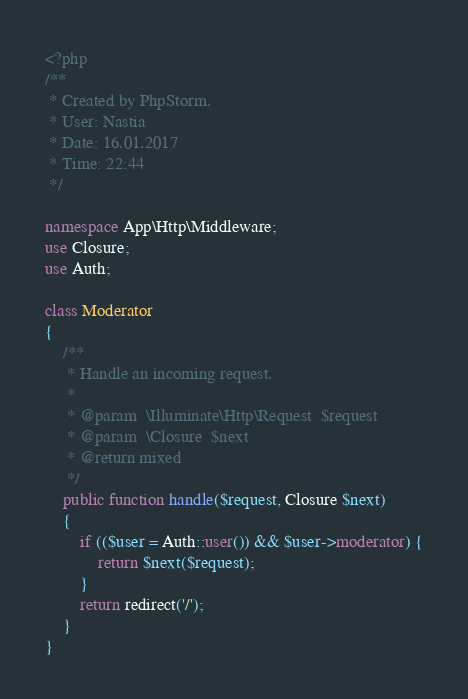Convert code to text. <code><loc_0><loc_0><loc_500><loc_500><_PHP_><?php
/**
 * Created by PhpStorm.
 * User: Nastia
 * Date: 16.01.2017
 * Time: 22:44
 */

namespace App\Http\Middleware;
use Closure;
use Auth;

class Moderator
{
    /**
     * Handle an incoming request.
     *
     * @param  \Illuminate\Http\Request  $request
     * @param  \Closure  $next
     * @return mixed
     */
    public function handle($request, Closure $next)
    {
        if (($user = Auth::user()) && $user->moderator) {
            return $next($request);
        }
        return redirect('/');
    }
}</code> 